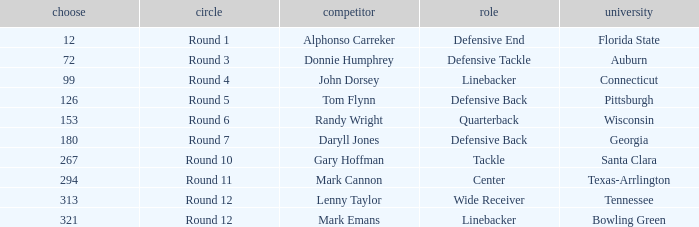In what Round was a player from College of Connecticut drafted? Round 4. 